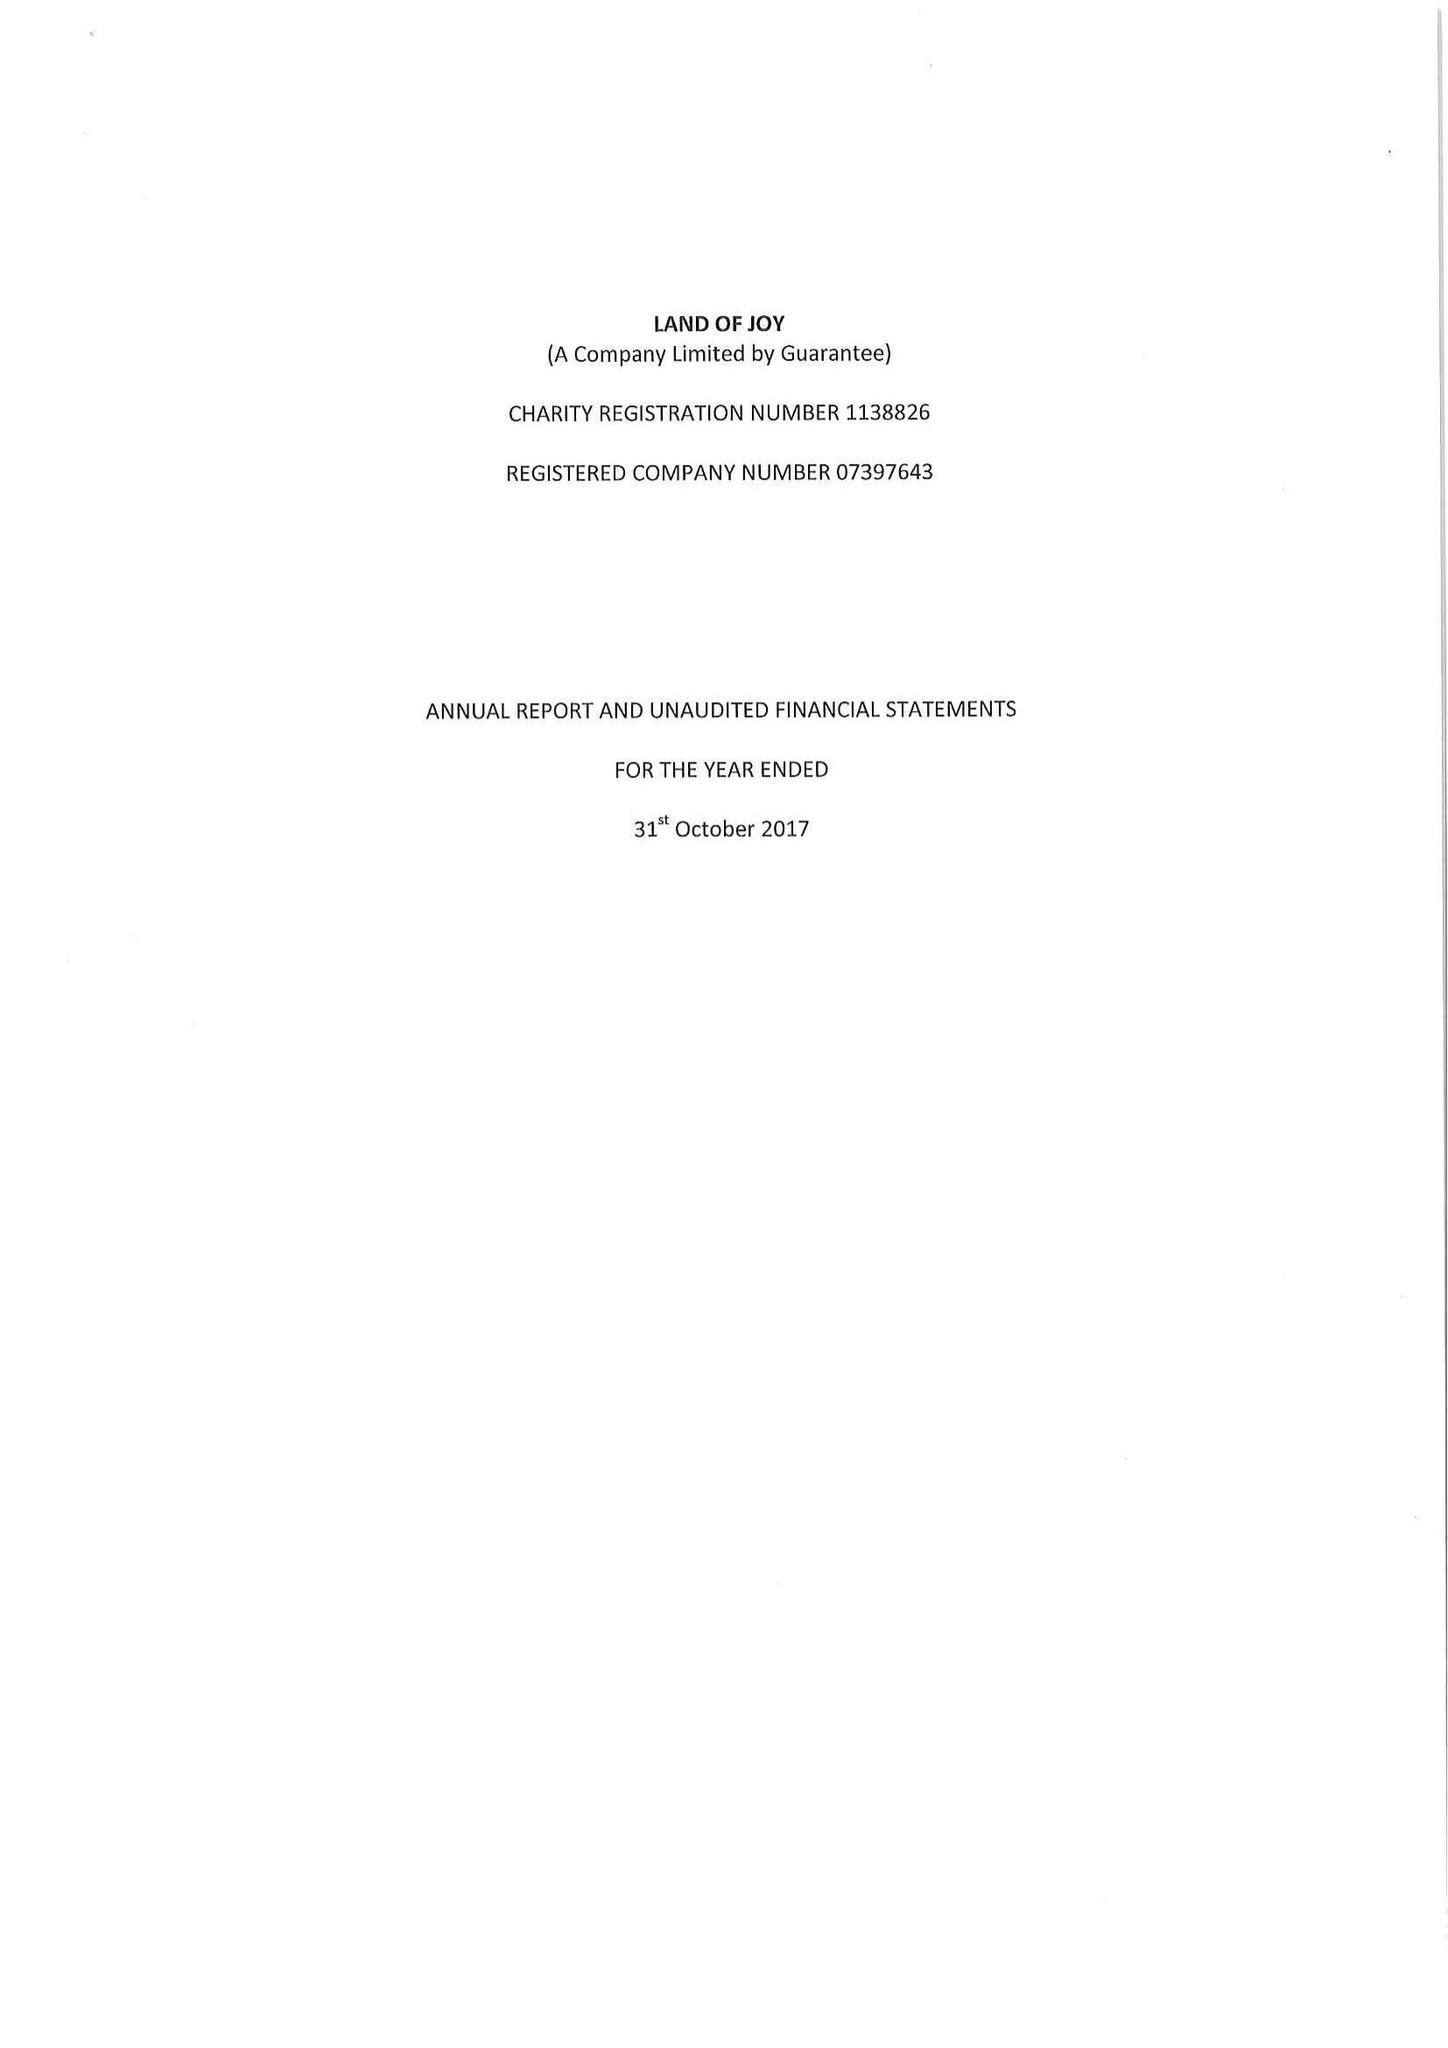What is the value for the report_date?
Answer the question using a single word or phrase. 2017-10-31 